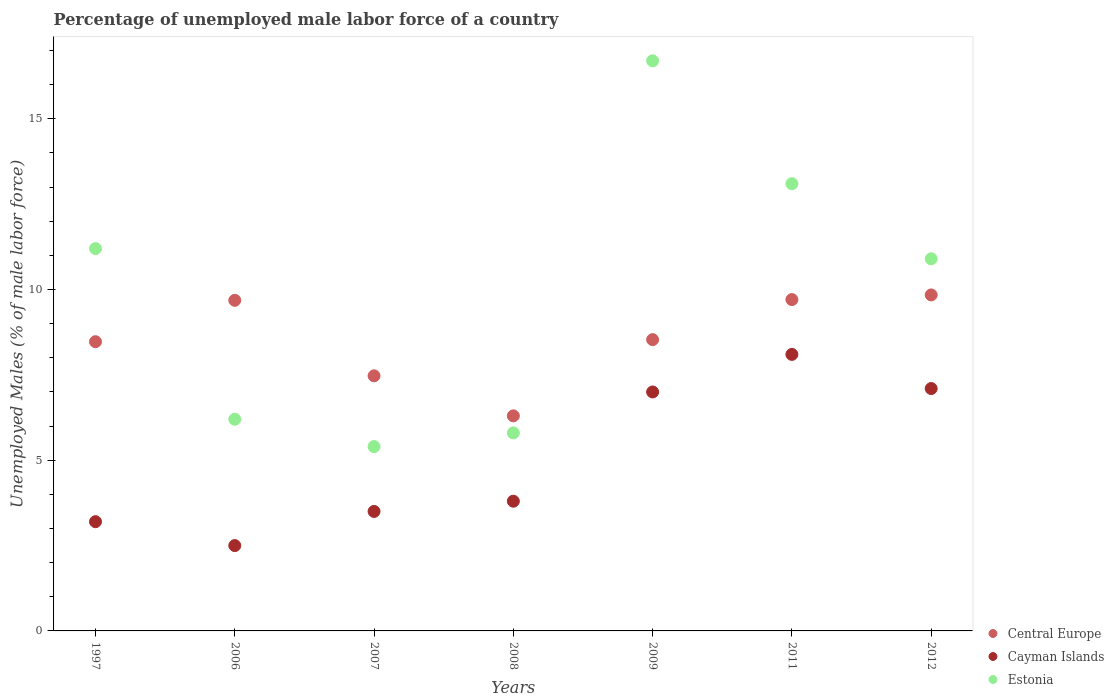How many different coloured dotlines are there?
Ensure brevity in your answer.  3. What is the percentage of unemployed male labor force in Cayman Islands in 2012?
Provide a succinct answer. 7.1. Across all years, what is the maximum percentage of unemployed male labor force in Cayman Islands?
Your answer should be very brief. 8.1. Across all years, what is the minimum percentage of unemployed male labor force in Central Europe?
Your answer should be compact. 6.3. In which year was the percentage of unemployed male labor force in Central Europe maximum?
Your response must be concise. 2012. What is the total percentage of unemployed male labor force in Estonia in the graph?
Offer a very short reply. 69.3. What is the difference between the percentage of unemployed male labor force in Estonia in 2009 and that in 2011?
Offer a terse response. 3.6. What is the difference between the percentage of unemployed male labor force in Cayman Islands in 2006 and the percentage of unemployed male labor force in Central Europe in 2007?
Provide a short and direct response. -4.97. What is the average percentage of unemployed male labor force in Central Europe per year?
Provide a short and direct response. 8.57. In the year 2009, what is the difference between the percentage of unemployed male labor force in Estonia and percentage of unemployed male labor force in Cayman Islands?
Your response must be concise. 9.7. What is the ratio of the percentage of unemployed male labor force in Cayman Islands in 2006 to that in 2008?
Make the answer very short. 0.66. Is the difference between the percentage of unemployed male labor force in Estonia in 1997 and 2011 greater than the difference between the percentage of unemployed male labor force in Cayman Islands in 1997 and 2011?
Provide a succinct answer. Yes. What is the difference between the highest and the second highest percentage of unemployed male labor force in Cayman Islands?
Give a very brief answer. 1. What is the difference between the highest and the lowest percentage of unemployed male labor force in Estonia?
Give a very brief answer. 11.3. Is it the case that in every year, the sum of the percentage of unemployed male labor force in Cayman Islands and percentage of unemployed male labor force in Estonia  is greater than the percentage of unemployed male labor force in Central Europe?
Offer a very short reply. No. Is the percentage of unemployed male labor force in Estonia strictly greater than the percentage of unemployed male labor force in Central Europe over the years?
Your answer should be very brief. No. What is the difference between two consecutive major ticks on the Y-axis?
Offer a terse response. 5. Are the values on the major ticks of Y-axis written in scientific E-notation?
Offer a very short reply. No. Does the graph contain grids?
Your answer should be very brief. No. How many legend labels are there?
Give a very brief answer. 3. What is the title of the graph?
Ensure brevity in your answer.  Percentage of unemployed male labor force of a country. What is the label or title of the Y-axis?
Your answer should be compact. Unemployed Males (% of male labor force). What is the Unemployed Males (% of male labor force) of Central Europe in 1997?
Your response must be concise. 8.47. What is the Unemployed Males (% of male labor force) in Cayman Islands in 1997?
Provide a short and direct response. 3.2. What is the Unemployed Males (% of male labor force) in Estonia in 1997?
Offer a terse response. 11.2. What is the Unemployed Males (% of male labor force) in Central Europe in 2006?
Your response must be concise. 9.68. What is the Unemployed Males (% of male labor force) in Cayman Islands in 2006?
Offer a very short reply. 2.5. What is the Unemployed Males (% of male labor force) in Estonia in 2006?
Your response must be concise. 6.2. What is the Unemployed Males (% of male labor force) of Central Europe in 2007?
Provide a short and direct response. 7.47. What is the Unemployed Males (% of male labor force) in Estonia in 2007?
Provide a succinct answer. 5.4. What is the Unemployed Males (% of male labor force) in Central Europe in 2008?
Your answer should be compact. 6.3. What is the Unemployed Males (% of male labor force) in Cayman Islands in 2008?
Your answer should be very brief. 3.8. What is the Unemployed Males (% of male labor force) of Estonia in 2008?
Make the answer very short. 5.8. What is the Unemployed Males (% of male labor force) of Central Europe in 2009?
Offer a terse response. 8.53. What is the Unemployed Males (% of male labor force) of Cayman Islands in 2009?
Keep it short and to the point. 7. What is the Unemployed Males (% of male labor force) of Estonia in 2009?
Make the answer very short. 16.7. What is the Unemployed Males (% of male labor force) of Central Europe in 2011?
Provide a succinct answer. 9.71. What is the Unemployed Males (% of male labor force) of Cayman Islands in 2011?
Keep it short and to the point. 8.1. What is the Unemployed Males (% of male labor force) in Estonia in 2011?
Make the answer very short. 13.1. What is the Unemployed Males (% of male labor force) in Central Europe in 2012?
Your response must be concise. 9.84. What is the Unemployed Males (% of male labor force) in Cayman Islands in 2012?
Your answer should be very brief. 7.1. What is the Unemployed Males (% of male labor force) of Estonia in 2012?
Keep it short and to the point. 10.9. Across all years, what is the maximum Unemployed Males (% of male labor force) of Central Europe?
Your response must be concise. 9.84. Across all years, what is the maximum Unemployed Males (% of male labor force) of Cayman Islands?
Provide a succinct answer. 8.1. Across all years, what is the maximum Unemployed Males (% of male labor force) in Estonia?
Your answer should be compact. 16.7. Across all years, what is the minimum Unemployed Males (% of male labor force) of Central Europe?
Your answer should be compact. 6.3. Across all years, what is the minimum Unemployed Males (% of male labor force) of Cayman Islands?
Your response must be concise. 2.5. Across all years, what is the minimum Unemployed Males (% of male labor force) in Estonia?
Make the answer very short. 5.4. What is the total Unemployed Males (% of male labor force) of Central Europe in the graph?
Make the answer very short. 60.01. What is the total Unemployed Males (% of male labor force) of Cayman Islands in the graph?
Ensure brevity in your answer.  35.2. What is the total Unemployed Males (% of male labor force) of Estonia in the graph?
Offer a terse response. 69.3. What is the difference between the Unemployed Males (% of male labor force) of Central Europe in 1997 and that in 2006?
Ensure brevity in your answer.  -1.21. What is the difference between the Unemployed Males (% of male labor force) in Estonia in 1997 and that in 2006?
Your response must be concise. 5. What is the difference between the Unemployed Males (% of male labor force) of Cayman Islands in 1997 and that in 2007?
Your response must be concise. -0.3. What is the difference between the Unemployed Males (% of male labor force) of Estonia in 1997 and that in 2007?
Keep it short and to the point. 5.8. What is the difference between the Unemployed Males (% of male labor force) in Central Europe in 1997 and that in 2008?
Your response must be concise. 2.17. What is the difference between the Unemployed Males (% of male labor force) of Cayman Islands in 1997 and that in 2008?
Your answer should be compact. -0.6. What is the difference between the Unemployed Males (% of male labor force) of Estonia in 1997 and that in 2008?
Offer a very short reply. 5.4. What is the difference between the Unemployed Males (% of male labor force) of Central Europe in 1997 and that in 2009?
Your response must be concise. -0.06. What is the difference between the Unemployed Males (% of male labor force) of Central Europe in 1997 and that in 2011?
Offer a very short reply. -1.23. What is the difference between the Unemployed Males (% of male labor force) in Central Europe in 1997 and that in 2012?
Provide a short and direct response. -1.37. What is the difference between the Unemployed Males (% of male labor force) in Estonia in 1997 and that in 2012?
Make the answer very short. 0.3. What is the difference between the Unemployed Males (% of male labor force) of Central Europe in 2006 and that in 2007?
Provide a succinct answer. 2.21. What is the difference between the Unemployed Males (% of male labor force) in Central Europe in 2006 and that in 2008?
Offer a terse response. 3.38. What is the difference between the Unemployed Males (% of male labor force) of Central Europe in 2006 and that in 2009?
Your answer should be very brief. 1.15. What is the difference between the Unemployed Males (% of male labor force) of Central Europe in 2006 and that in 2011?
Your answer should be compact. -0.02. What is the difference between the Unemployed Males (% of male labor force) of Cayman Islands in 2006 and that in 2011?
Give a very brief answer. -5.6. What is the difference between the Unemployed Males (% of male labor force) in Central Europe in 2006 and that in 2012?
Your answer should be compact. -0.16. What is the difference between the Unemployed Males (% of male labor force) of Central Europe in 2007 and that in 2008?
Keep it short and to the point. 1.17. What is the difference between the Unemployed Males (% of male labor force) in Central Europe in 2007 and that in 2009?
Your response must be concise. -1.06. What is the difference between the Unemployed Males (% of male labor force) of Cayman Islands in 2007 and that in 2009?
Provide a short and direct response. -3.5. What is the difference between the Unemployed Males (% of male labor force) in Estonia in 2007 and that in 2009?
Your answer should be very brief. -11.3. What is the difference between the Unemployed Males (% of male labor force) in Central Europe in 2007 and that in 2011?
Ensure brevity in your answer.  -2.23. What is the difference between the Unemployed Males (% of male labor force) of Central Europe in 2007 and that in 2012?
Your response must be concise. -2.37. What is the difference between the Unemployed Males (% of male labor force) of Cayman Islands in 2007 and that in 2012?
Give a very brief answer. -3.6. What is the difference between the Unemployed Males (% of male labor force) of Estonia in 2007 and that in 2012?
Your answer should be compact. -5.5. What is the difference between the Unemployed Males (% of male labor force) of Central Europe in 2008 and that in 2009?
Offer a very short reply. -2.23. What is the difference between the Unemployed Males (% of male labor force) of Cayman Islands in 2008 and that in 2009?
Make the answer very short. -3.2. What is the difference between the Unemployed Males (% of male labor force) of Estonia in 2008 and that in 2009?
Provide a succinct answer. -10.9. What is the difference between the Unemployed Males (% of male labor force) in Central Europe in 2008 and that in 2011?
Your response must be concise. -3.41. What is the difference between the Unemployed Males (% of male labor force) of Cayman Islands in 2008 and that in 2011?
Provide a short and direct response. -4.3. What is the difference between the Unemployed Males (% of male labor force) in Estonia in 2008 and that in 2011?
Ensure brevity in your answer.  -7.3. What is the difference between the Unemployed Males (% of male labor force) in Central Europe in 2008 and that in 2012?
Give a very brief answer. -3.54. What is the difference between the Unemployed Males (% of male labor force) of Estonia in 2008 and that in 2012?
Your answer should be compact. -5.1. What is the difference between the Unemployed Males (% of male labor force) in Central Europe in 2009 and that in 2011?
Make the answer very short. -1.17. What is the difference between the Unemployed Males (% of male labor force) in Estonia in 2009 and that in 2011?
Keep it short and to the point. 3.6. What is the difference between the Unemployed Males (% of male labor force) in Central Europe in 2009 and that in 2012?
Your answer should be compact. -1.31. What is the difference between the Unemployed Males (% of male labor force) of Central Europe in 2011 and that in 2012?
Offer a terse response. -0.14. What is the difference between the Unemployed Males (% of male labor force) of Cayman Islands in 2011 and that in 2012?
Provide a succinct answer. 1. What is the difference between the Unemployed Males (% of male labor force) in Central Europe in 1997 and the Unemployed Males (% of male labor force) in Cayman Islands in 2006?
Your answer should be very brief. 5.97. What is the difference between the Unemployed Males (% of male labor force) of Central Europe in 1997 and the Unemployed Males (% of male labor force) of Estonia in 2006?
Offer a very short reply. 2.27. What is the difference between the Unemployed Males (% of male labor force) in Cayman Islands in 1997 and the Unemployed Males (% of male labor force) in Estonia in 2006?
Your response must be concise. -3. What is the difference between the Unemployed Males (% of male labor force) in Central Europe in 1997 and the Unemployed Males (% of male labor force) in Cayman Islands in 2007?
Provide a short and direct response. 4.97. What is the difference between the Unemployed Males (% of male labor force) of Central Europe in 1997 and the Unemployed Males (% of male labor force) of Estonia in 2007?
Offer a very short reply. 3.07. What is the difference between the Unemployed Males (% of male labor force) in Cayman Islands in 1997 and the Unemployed Males (% of male labor force) in Estonia in 2007?
Ensure brevity in your answer.  -2.2. What is the difference between the Unemployed Males (% of male labor force) of Central Europe in 1997 and the Unemployed Males (% of male labor force) of Cayman Islands in 2008?
Keep it short and to the point. 4.67. What is the difference between the Unemployed Males (% of male labor force) in Central Europe in 1997 and the Unemployed Males (% of male labor force) in Estonia in 2008?
Offer a terse response. 2.67. What is the difference between the Unemployed Males (% of male labor force) of Cayman Islands in 1997 and the Unemployed Males (% of male labor force) of Estonia in 2008?
Make the answer very short. -2.6. What is the difference between the Unemployed Males (% of male labor force) of Central Europe in 1997 and the Unemployed Males (% of male labor force) of Cayman Islands in 2009?
Ensure brevity in your answer.  1.47. What is the difference between the Unemployed Males (% of male labor force) of Central Europe in 1997 and the Unemployed Males (% of male labor force) of Estonia in 2009?
Your answer should be very brief. -8.23. What is the difference between the Unemployed Males (% of male labor force) in Cayman Islands in 1997 and the Unemployed Males (% of male labor force) in Estonia in 2009?
Give a very brief answer. -13.5. What is the difference between the Unemployed Males (% of male labor force) of Central Europe in 1997 and the Unemployed Males (% of male labor force) of Cayman Islands in 2011?
Ensure brevity in your answer.  0.37. What is the difference between the Unemployed Males (% of male labor force) of Central Europe in 1997 and the Unemployed Males (% of male labor force) of Estonia in 2011?
Keep it short and to the point. -4.63. What is the difference between the Unemployed Males (% of male labor force) of Cayman Islands in 1997 and the Unemployed Males (% of male labor force) of Estonia in 2011?
Make the answer very short. -9.9. What is the difference between the Unemployed Males (% of male labor force) in Central Europe in 1997 and the Unemployed Males (% of male labor force) in Cayman Islands in 2012?
Offer a very short reply. 1.37. What is the difference between the Unemployed Males (% of male labor force) in Central Europe in 1997 and the Unemployed Males (% of male labor force) in Estonia in 2012?
Make the answer very short. -2.43. What is the difference between the Unemployed Males (% of male labor force) in Central Europe in 2006 and the Unemployed Males (% of male labor force) in Cayman Islands in 2007?
Ensure brevity in your answer.  6.18. What is the difference between the Unemployed Males (% of male labor force) of Central Europe in 2006 and the Unemployed Males (% of male labor force) of Estonia in 2007?
Ensure brevity in your answer.  4.28. What is the difference between the Unemployed Males (% of male labor force) in Cayman Islands in 2006 and the Unemployed Males (% of male labor force) in Estonia in 2007?
Make the answer very short. -2.9. What is the difference between the Unemployed Males (% of male labor force) in Central Europe in 2006 and the Unemployed Males (% of male labor force) in Cayman Islands in 2008?
Provide a short and direct response. 5.88. What is the difference between the Unemployed Males (% of male labor force) in Central Europe in 2006 and the Unemployed Males (% of male labor force) in Estonia in 2008?
Your answer should be very brief. 3.88. What is the difference between the Unemployed Males (% of male labor force) of Central Europe in 2006 and the Unemployed Males (% of male labor force) of Cayman Islands in 2009?
Your answer should be compact. 2.68. What is the difference between the Unemployed Males (% of male labor force) of Central Europe in 2006 and the Unemployed Males (% of male labor force) of Estonia in 2009?
Ensure brevity in your answer.  -7.02. What is the difference between the Unemployed Males (% of male labor force) in Cayman Islands in 2006 and the Unemployed Males (% of male labor force) in Estonia in 2009?
Provide a short and direct response. -14.2. What is the difference between the Unemployed Males (% of male labor force) of Central Europe in 2006 and the Unemployed Males (% of male labor force) of Cayman Islands in 2011?
Provide a succinct answer. 1.58. What is the difference between the Unemployed Males (% of male labor force) of Central Europe in 2006 and the Unemployed Males (% of male labor force) of Estonia in 2011?
Make the answer very short. -3.42. What is the difference between the Unemployed Males (% of male labor force) of Central Europe in 2006 and the Unemployed Males (% of male labor force) of Cayman Islands in 2012?
Make the answer very short. 2.58. What is the difference between the Unemployed Males (% of male labor force) of Central Europe in 2006 and the Unemployed Males (% of male labor force) of Estonia in 2012?
Offer a terse response. -1.22. What is the difference between the Unemployed Males (% of male labor force) in Cayman Islands in 2006 and the Unemployed Males (% of male labor force) in Estonia in 2012?
Provide a succinct answer. -8.4. What is the difference between the Unemployed Males (% of male labor force) of Central Europe in 2007 and the Unemployed Males (% of male labor force) of Cayman Islands in 2008?
Offer a terse response. 3.67. What is the difference between the Unemployed Males (% of male labor force) in Central Europe in 2007 and the Unemployed Males (% of male labor force) in Estonia in 2008?
Provide a short and direct response. 1.67. What is the difference between the Unemployed Males (% of male labor force) in Cayman Islands in 2007 and the Unemployed Males (% of male labor force) in Estonia in 2008?
Provide a succinct answer. -2.3. What is the difference between the Unemployed Males (% of male labor force) of Central Europe in 2007 and the Unemployed Males (% of male labor force) of Cayman Islands in 2009?
Your response must be concise. 0.47. What is the difference between the Unemployed Males (% of male labor force) of Central Europe in 2007 and the Unemployed Males (% of male labor force) of Estonia in 2009?
Your response must be concise. -9.23. What is the difference between the Unemployed Males (% of male labor force) of Cayman Islands in 2007 and the Unemployed Males (% of male labor force) of Estonia in 2009?
Give a very brief answer. -13.2. What is the difference between the Unemployed Males (% of male labor force) of Central Europe in 2007 and the Unemployed Males (% of male labor force) of Cayman Islands in 2011?
Make the answer very short. -0.63. What is the difference between the Unemployed Males (% of male labor force) of Central Europe in 2007 and the Unemployed Males (% of male labor force) of Estonia in 2011?
Your answer should be very brief. -5.63. What is the difference between the Unemployed Males (% of male labor force) in Cayman Islands in 2007 and the Unemployed Males (% of male labor force) in Estonia in 2011?
Your answer should be very brief. -9.6. What is the difference between the Unemployed Males (% of male labor force) in Central Europe in 2007 and the Unemployed Males (% of male labor force) in Cayman Islands in 2012?
Ensure brevity in your answer.  0.37. What is the difference between the Unemployed Males (% of male labor force) in Central Europe in 2007 and the Unemployed Males (% of male labor force) in Estonia in 2012?
Ensure brevity in your answer.  -3.43. What is the difference between the Unemployed Males (% of male labor force) in Cayman Islands in 2007 and the Unemployed Males (% of male labor force) in Estonia in 2012?
Provide a succinct answer. -7.4. What is the difference between the Unemployed Males (% of male labor force) of Central Europe in 2008 and the Unemployed Males (% of male labor force) of Cayman Islands in 2009?
Your response must be concise. -0.7. What is the difference between the Unemployed Males (% of male labor force) in Central Europe in 2008 and the Unemployed Males (% of male labor force) in Estonia in 2009?
Ensure brevity in your answer.  -10.4. What is the difference between the Unemployed Males (% of male labor force) of Cayman Islands in 2008 and the Unemployed Males (% of male labor force) of Estonia in 2009?
Provide a short and direct response. -12.9. What is the difference between the Unemployed Males (% of male labor force) of Central Europe in 2008 and the Unemployed Males (% of male labor force) of Cayman Islands in 2011?
Offer a terse response. -1.8. What is the difference between the Unemployed Males (% of male labor force) in Central Europe in 2008 and the Unemployed Males (% of male labor force) in Estonia in 2011?
Ensure brevity in your answer.  -6.8. What is the difference between the Unemployed Males (% of male labor force) of Central Europe in 2008 and the Unemployed Males (% of male labor force) of Cayman Islands in 2012?
Make the answer very short. -0.8. What is the difference between the Unemployed Males (% of male labor force) in Central Europe in 2008 and the Unemployed Males (% of male labor force) in Estonia in 2012?
Offer a very short reply. -4.6. What is the difference between the Unemployed Males (% of male labor force) of Cayman Islands in 2008 and the Unemployed Males (% of male labor force) of Estonia in 2012?
Offer a terse response. -7.1. What is the difference between the Unemployed Males (% of male labor force) of Central Europe in 2009 and the Unemployed Males (% of male labor force) of Cayman Islands in 2011?
Offer a terse response. 0.43. What is the difference between the Unemployed Males (% of male labor force) in Central Europe in 2009 and the Unemployed Males (% of male labor force) in Estonia in 2011?
Offer a terse response. -4.57. What is the difference between the Unemployed Males (% of male labor force) of Cayman Islands in 2009 and the Unemployed Males (% of male labor force) of Estonia in 2011?
Provide a short and direct response. -6.1. What is the difference between the Unemployed Males (% of male labor force) of Central Europe in 2009 and the Unemployed Males (% of male labor force) of Cayman Islands in 2012?
Your answer should be very brief. 1.43. What is the difference between the Unemployed Males (% of male labor force) in Central Europe in 2009 and the Unemployed Males (% of male labor force) in Estonia in 2012?
Your answer should be compact. -2.37. What is the difference between the Unemployed Males (% of male labor force) of Central Europe in 2011 and the Unemployed Males (% of male labor force) of Cayman Islands in 2012?
Provide a short and direct response. 2.61. What is the difference between the Unemployed Males (% of male labor force) in Central Europe in 2011 and the Unemployed Males (% of male labor force) in Estonia in 2012?
Ensure brevity in your answer.  -1.19. What is the average Unemployed Males (% of male labor force) of Central Europe per year?
Your response must be concise. 8.57. What is the average Unemployed Males (% of male labor force) of Cayman Islands per year?
Your answer should be compact. 5.03. What is the average Unemployed Males (% of male labor force) of Estonia per year?
Provide a short and direct response. 9.9. In the year 1997, what is the difference between the Unemployed Males (% of male labor force) of Central Europe and Unemployed Males (% of male labor force) of Cayman Islands?
Give a very brief answer. 5.27. In the year 1997, what is the difference between the Unemployed Males (% of male labor force) in Central Europe and Unemployed Males (% of male labor force) in Estonia?
Offer a very short reply. -2.73. In the year 1997, what is the difference between the Unemployed Males (% of male labor force) in Cayman Islands and Unemployed Males (% of male labor force) in Estonia?
Offer a terse response. -8. In the year 2006, what is the difference between the Unemployed Males (% of male labor force) of Central Europe and Unemployed Males (% of male labor force) of Cayman Islands?
Give a very brief answer. 7.18. In the year 2006, what is the difference between the Unemployed Males (% of male labor force) in Central Europe and Unemployed Males (% of male labor force) in Estonia?
Offer a very short reply. 3.48. In the year 2006, what is the difference between the Unemployed Males (% of male labor force) of Cayman Islands and Unemployed Males (% of male labor force) of Estonia?
Your answer should be very brief. -3.7. In the year 2007, what is the difference between the Unemployed Males (% of male labor force) in Central Europe and Unemployed Males (% of male labor force) in Cayman Islands?
Keep it short and to the point. 3.97. In the year 2007, what is the difference between the Unemployed Males (% of male labor force) of Central Europe and Unemployed Males (% of male labor force) of Estonia?
Your response must be concise. 2.07. In the year 2007, what is the difference between the Unemployed Males (% of male labor force) in Cayman Islands and Unemployed Males (% of male labor force) in Estonia?
Ensure brevity in your answer.  -1.9. In the year 2008, what is the difference between the Unemployed Males (% of male labor force) in Central Europe and Unemployed Males (% of male labor force) in Cayman Islands?
Provide a succinct answer. 2.5. In the year 2008, what is the difference between the Unemployed Males (% of male labor force) in Central Europe and Unemployed Males (% of male labor force) in Estonia?
Make the answer very short. 0.5. In the year 2008, what is the difference between the Unemployed Males (% of male labor force) in Cayman Islands and Unemployed Males (% of male labor force) in Estonia?
Make the answer very short. -2. In the year 2009, what is the difference between the Unemployed Males (% of male labor force) of Central Europe and Unemployed Males (% of male labor force) of Cayman Islands?
Your response must be concise. 1.53. In the year 2009, what is the difference between the Unemployed Males (% of male labor force) of Central Europe and Unemployed Males (% of male labor force) of Estonia?
Ensure brevity in your answer.  -8.17. In the year 2011, what is the difference between the Unemployed Males (% of male labor force) in Central Europe and Unemployed Males (% of male labor force) in Cayman Islands?
Offer a very short reply. 1.61. In the year 2011, what is the difference between the Unemployed Males (% of male labor force) in Central Europe and Unemployed Males (% of male labor force) in Estonia?
Your response must be concise. -3.39. In the year 2011, what is the difference between the Unemployed Males (% of male labor force) of Cayman Islands and Unemployed Males (% of male labor force) of Estonia?
Ensure brevity in your answer.  -5. In the year 2012, what is the difference between the Unemployed Males (% of male labor force) of Central Europe and Unemployed Males (% of male labor force) of Cayman Islands?
Offer a very short reply. 2.74. In the year 2012, what is the difference between the Unemployed Males (% of male labor force) in Central Europe and Unemployed Males (% of male labor force) in Estonia?
Ensure brevity in your answer.  -1.06. In the year 2012, what is the difference between the Unemployed Males (% of male labor force) in Cayman Islands and Unemployed Males (% of male labor force) in Estonia?
Your answer should be compact. -3.8. What is the ratio of the Unemployed Males (% of male labor force) in Central Europe in 1997 to that in 2006?
Provide a succinct answer. 0.87. What is the ratio of the Unemployed Males (% of male labor force) in Cayman Islands in 1997 to that in 2006?
Give a very brief answer. 1.28. What is the ratio of the Unemployed Males (% of male labor force) of Estonia in 1997 to that in 2006?
Your response must be concise. 1.81. What is the ratio of the Unemployed Males (% of male labor force) of Central Europe in 1997 to that in 2007?
Make the answer very short. 1.13. What is the ratio of the Unemployed Males (% of male labor force) in Cayman Islands in 1997 to that in 2007?
Your answer should be very brief. 0.91. What is the ratio of the Unemployed Males (% of male labor force) of Estonia in 1997 to that in 2007?
Offer a terse response. 2.07. What is the ratio of the Unemployed Males (% of male labor force) in Central Europe in 1997 to that in 2008?
Offer a terse response. 1.34. What is the ratio of the Unemployed Males (% of male labor force) of Cayman Islands in 1997 to that in 2008?
Make the answer very short. 0.84. What is the ratio of the Unemployed Males (% of male labor force) in Estonia in 1997 to that in 2008?
Ensure brevity in your answer.  1.93. What is the ratio of the Unemployed Males (% of male labor force) of Cayman Islands in 1997 to that in 2009?
Give a very brief answer. 0.46. What is the ratio of the Unemployed Males (% of male labor force) in Estonia in 1997 to that in 2009?
Provide a succinct answer. 0.67. What is the ratio of the Unemployed Males (% of male labor force) in Central Europe in 1997 to that in 2011?
Your answer should be compact. 0.87. What is the ratio of the Unemployed Males (% of male labor force) in Cayman Islands in 1997 to that in 2011?
Your answer should be very brief. 0.4. What is the ratio of the Unemployed Males (% of male labor force) of Estonia in 1997 to that in 2011?
Give a very brief answer. 0.85. What is the ratio of the Unemployed Males (% of male labor force) of Central Europe in 1997 to that in 2012?
Offer a very short reply. 0.86. What is the ratio of the Unemployed Males (% of male labor force) in Cayman Islands in 1997 to that in 2012?
Give a very brief answer. 0.45. What is the ratio of the Unemployed Males (% of male labor force) of Estonia in 1997 to that in 2012?
Provide a short and direct response. 1.03. What is the ratio of the Unemployed Males (% of male labor force) in Central Europe in 2006 to that in 2007?
Your answer should be very brief. 1.3. What is the ratio of the Unemployed Males (% of male labor force) in Estonia in 2006 to that in 2007?
Provide a succinct answer. 1.15. What is the ratio of the Unemployed Males (% of male labor force) in Central Europe in 2006 to that in 2008?
Offer a terse response. 1.54. What is the ratio of the Unemployed Males (% of male labor force) in Cayman Islands in 2006 to that in 2008?
Your answer should be compact. 0.66. What is the ratio of the Unemployed Males (% of male labor force) in Estonia in 2006 to that in 2008?
Your answer should be very brief. 1.07. What is the ratio of the Unemployed Males (% of male labor force) of Central Europe in 2006 to that in 2009?
Provide a succinct answer. 1.14. What is the ratio of the Unemployed Males (% of male labor force) of Cayman Islands in 2006 to that in 2009?
Make the answer very short. 0.36. What is the ratio of the Unemployed Males (% of male labor force) in Estonia in 2006 to that in 2009?
Make the answer very short. 0.37. What is the ratio of the Unemployed Males (% of male labor force) of Cayman Islands in 2006 to that in 2011?
Offer a terse response. 0.31. What is the ratio of the Unemployed Males (% of male labor force) of Estonia in 2006 to that in 2011?
Provide a succinct answer. 0.47. What is the ratio of the Unemployed Males (% of male labor force) of Central Europe in 2006 to that in 2012?
Your response must be concise. 0.98. What is the ratio of the Unemployed Males (% of male labor force) in Cayman Islands in 2006 to that in 2012?
Your answer should be compact. 0.35. What is the ratio of the Unemployed Males (% of male labor force) in Estonia in 2006 to that in 2012?
Your response must be concise. 0.57. What is the ratio of the Unemployed Males (% of male labor force) in Central Europe in 2007 to that in 2008?
Your answer should be compact. 1.19. What is the ratio of the Unemployed Males (% of male labor force) in Cayman Islands in 2007 to that in 2008?
Give a very brief answer. 0.92. What is the ratio of the Unemployed Males (% of male labor force) in Estonia in 2007 to that in 2008?
Your response must be concise. 0.93. What is the ratio of the Unemployed Males (% of male labor force) in Central Europe in 2007 to that in 2009?
Provide a short and direct response. 0.88. What is the ratio of the Unemployed Males (% of male labor force) in Cayman Islands in 2007 to that in 2009?
Your answer should be very brief. 0.5. What is the ratio of the Unemployed Males (% of male labor force) in Estonia in 2007 to that in 2009?
Your response must be concise. 0.32. What is the ratio of the Unemployed Males (% of male labor force) in Central Europe in 2007 to that in 2011?
Ensure brevity in your answer.  0.77. What is the ratio of the Unemployed Males (% of male labor force) of Cayman Islands in 2007 to that in 2011?
Ensure brevity in your answer.  0.43. What is the ratio of the Unemployed Males (% of male labor force) in Estonia in 2007 to that in 2011?
Keep it short and to the point. 0.41. What is the ratio of the Unemployed Males (% of male labor force) in Central Europe in 2007 to that in 2012?
Offer a terse response. 0.76. What is the ratio of the Unemployed Males (% of male labor force) of Cayman Islands in 2007 to that in 2012?
Keep it short and to the point. 0.49. What is the ratio of the Unemployed Males (% of male labor force) in Estonia in 2007 to that in 2012?
Make the answer very short. 0.5. What is the ratio of the Unemployed Males (% of male labor force) in Central Europe in 2008 to that in 2009?
Your answer should be very brief. 0.74. What is the ratio of the Unemployed Males (% of male labor force) of Cayman Islands in 2008 to that in 2009?
Your answer should be very brief. 0.54. What is the ratio of the Unemployed Males (% of male labor force) of Estonia in 2008 to that in 2009?
Provide a succinct answer. 0.35. What is the ratio of the Unemployed Males (% of male labor force) in Central Europe in 2008 to that in 2011?
Your response must be concise. 0.65. What is the ratio of the Unemployed Males (% of male labor force) of Cayman Islands in 2008 to that in 2011?
Give a very brief answer. 0.47. What is the ratio of the Unemployed Males (% of male labor force) in Estonia in 2008 to that in 2011?
Provide a short and direct response. 0.44. What is the ratio of the Unemployed Males (% of male labor force) in Central Europe in 2008 to that in 2012?
Keep it short and to the point. 0.64. What is the ratio of the Unemployed Males (% of male labor force) in Cayman Islands in 2008 to that in 2012?
Your answer should be compact. 0.54. What is the ratio of the Unemployed Males (% of male labor force) of Estonia in 2008 to that in 2012?
Give a very brief answer. 0.53. What is the ratio of the Unemployed Males (% of male labor force) of Central Europe in 2009 to that in 2011?
Make the answer very short. 0.88. What is the ratio of the Unemployed Males (% of male labor force) in Cayman Islands in 2009 to that in 2011?
Offer a terse response. 0.86. What is the ratio of the Unemployed Males (% of male labor force) in Estonia in 2009 to that in 2011?
Ensure brevity in your answer.  1.27. What is the ratio of the Unemployed Males (% of male labor force) in Central Europe in 2009 to that in 2012?
Your response must be concise. 0.87. What is the ratio of the Unemployed Males (% of male labor force) in Cayman Islands in 2009 to that in 2012?
Your answer should be compact. 0.99. What is the ratio of the Unemployed Males (% of male labor force) of Estonia in 2009 to that in 2012?
Keep it short and to the point. 1.53. What is the ratio of the Unemployed Males (% of male labor force) of Central Europe in 2011 to that in 2012?
Offer a terse response. 0.99. What is the ratio of the Unemployed Males (% of male labor force) in Cayman Islands in 2011 to that in 2012?
Your answer should be very brief. 1.14. What is the ratio of the Unemployed Males (% of male labor force) in Estonia in 2011 to that in 2012?
Your response must be concise. 1.2. What is the difference between the highest and the second highest Unemployed Males (% of male labor force) of Central Europe?
Your response must be concise. 0.14. What is the difference between the highest and the second highest Unemployed Males (% of male labor force) of Cayman Islands?
Give a very brief answer. 1. What is the difference between the highest and the lowest Unemployed Males (% of male labor force) in Central Europe?
Ensure brevity in your answer.  3.54. What is the difference between the highest and the lowest Unemployed Males (% of male labor force) in Cayman Islands?
Provide a short and direct response. 5.6. What is the difference between the highest and the lowest Unemployed Males (% of male labor force) in Estonia?
Provide a short and direct response. 11.3. 